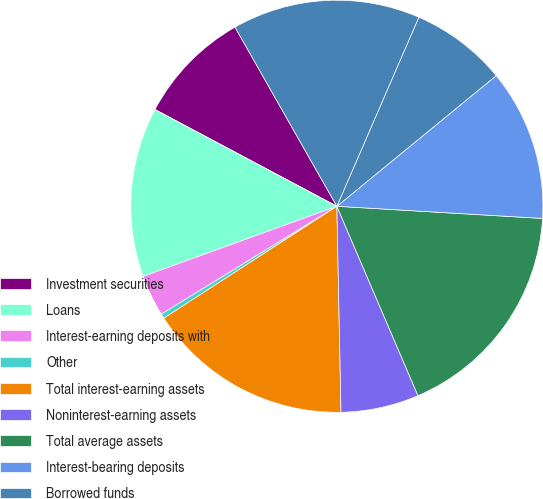<chart> <loc_0><loc_0><loc_500><loc_500><pie_chart><fcel>Investment securities<fcel>Loans<fcel>Interest-earning deposits with<fcel>Other<fcel>Total interest-earning assets<fcel>Noninterest-earning assets<fcel>Total average assets<fcel>Interest-bearing deposits<fcel>Borrowed funds<fcel>Total interest-bearing<nl><fcel>8.99%<fcel>13.31%<fcel>3.24%<fcel>0.37%<fcel>16.18%<fcel>6.12%<fcel>17.62%<fcel>11.87%<fcel>7.56%<fcel>14.74%<nl></chart> 